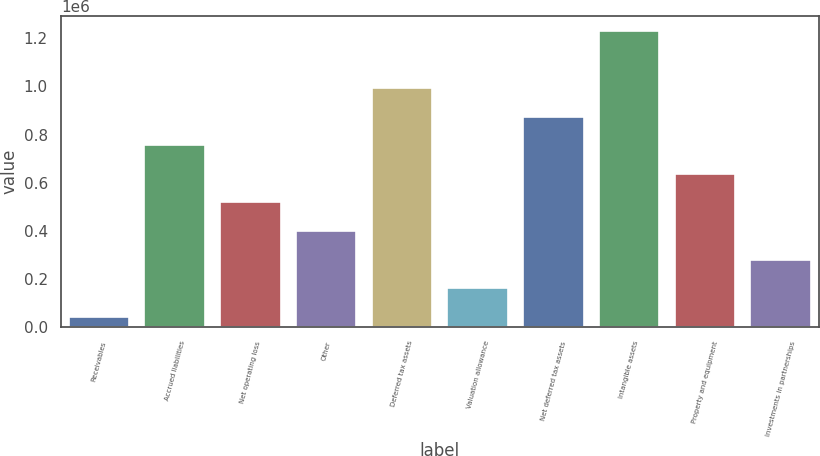<chart> <loc_0><loc_0><loc_500><loc_500><bar_chart><fcel>Receivables<fcel>Accrued liabilities<fcel>Net operating loss<fcel>Other<fcel>Deferred tax assets<fcel>Valuation allowance<fcel>Net deferred tax assets<fcel>Intangible assets<fcel>Property and equipment<fcel>Investments in partnerships<nl><fcel>43393<fcel>755601<fcel>518198<fcel>399497<fcel>993003<fcel>162094<fcel>874302<fcel>1.23041e+06<fcel>636900<fcel>280796<nl></chart> 